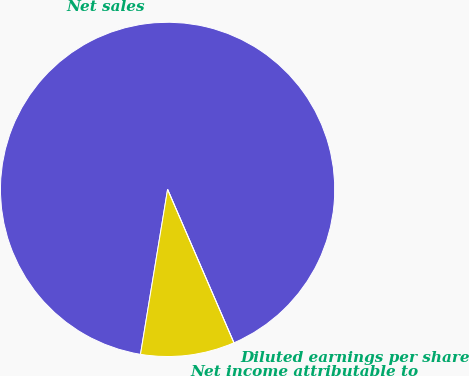Convert chart to OTSL. <chart><loc_0><loc_0><loc_500><loc_500><pie_chart><fcel>Net sales<fcel>Net income attributable to<fcel>Diluted earnings per share<nl><fcel>90.91%<fcel>9.09%<fcel>0.0%<nl></chart> 